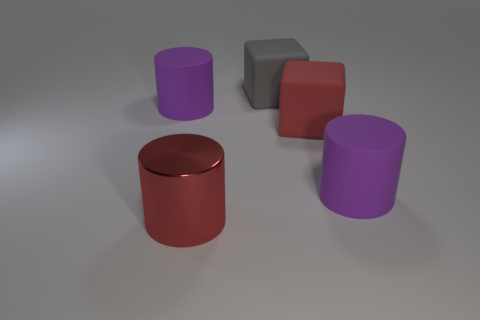There is another big thing that is the same color as the shiny thing; what is its material?
Give a very brief answer. Rubber. There is a big cylinder behind the big purple cylinder on the right side of the large thing on the left side of the large red shiny cylinder; what color is it?
Your response must be concise. Purple. Is there anything else that is the same size as the gray matte thing?
Provide a succinct answer. Yes. Does the large metallic thing have the same color as the rubber cylinder to the right of the large shiny cylinder?
Offer a terse response. No. What color is the large metallic thing?
Offer a terse response. Red. There is a large purple thing that is to the right of the metallic cylinder that is to the right of the purple cylinder that is behind the red matte cube; what shape is it?
Your response must be concise. Cylinder. How many other things are there of the same color as the metallic cylinder?
Offer a terse response. 1. Are there more gray rubber things in front of the large gray rubber block than large cylinders behind the metallic cylinder?
Ensure brevity in your answer.  No. There is a red cube; are there any large purple rubber cylinders to the right of it?
Your answer should be very brief. Yes. There is a object that is behind the large red cube and in front of the gray rubber cube; what material is it made of?
Give a very brief answer. Rubber. 